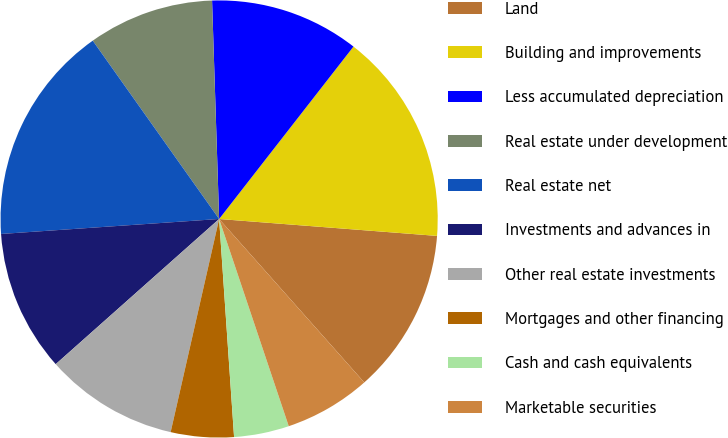Convert chart. <chart><loc_0><loc_0><loc_500><loc_500><pie_chart><fcel>Land<fcel>Building and improvements<fcel>Less accumulated depreciation<fcel>Real estate under development<fcel>Real estate net<fcel>Investments and advances in<fcel>Other real estate investments<fcel>Mortgages and other financing<fcel>Cash and cash equivalents<fcel>Marketable securities<nl><fcel>12.21%<fcel>15.7%<fcel>11.05%<fcel>9.3%<fcel>16.28%<fcel>10.47%<fcel>9.88%<fcel>4.65%<fcel>4.07%<fcel>6.4%<nl></chart> 